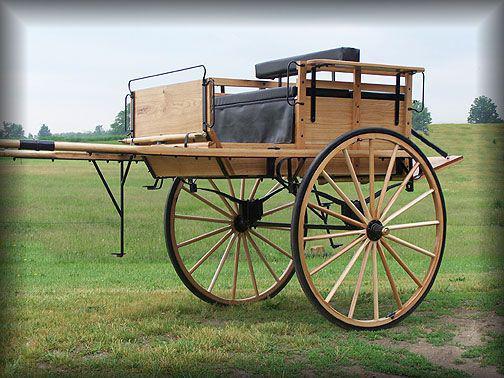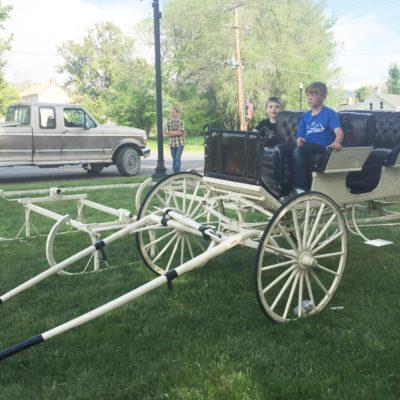The first image is the image on the left, the second image is the image on the right. For the images displayed, is the sentence "There is a white carriage led by a white horse in the left image." factually correct? Answer yes or no. No. The first image is the image on the left, the second image is the image on the right. Assess this claim about the two images: "There are humans riding in a carriage in the right image.". Correct or not? Answer yes or no. Yes. 